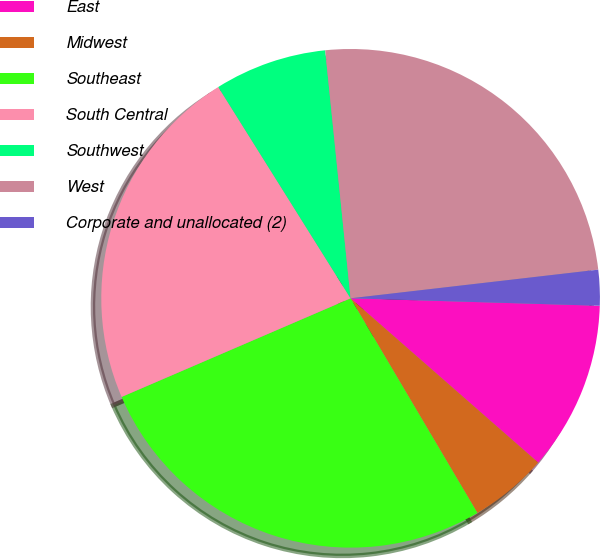Convert chart to OTSL. <chart><loc_0><loc_0><loc_500><loc_500><pie_chart><fcel>East<fcel>Midwest<fcel>Southeast<fcel>South Central<fcel>Southwest<fcel>West<fcel>Corporate and unallocated (2)<nl><fcel>10.97%<fcel>5.06%<fcel>27.02%<fcel>22.57%<fcel>7.28%<fcel>24.79%<fcel>2.31%<nl></chart> 